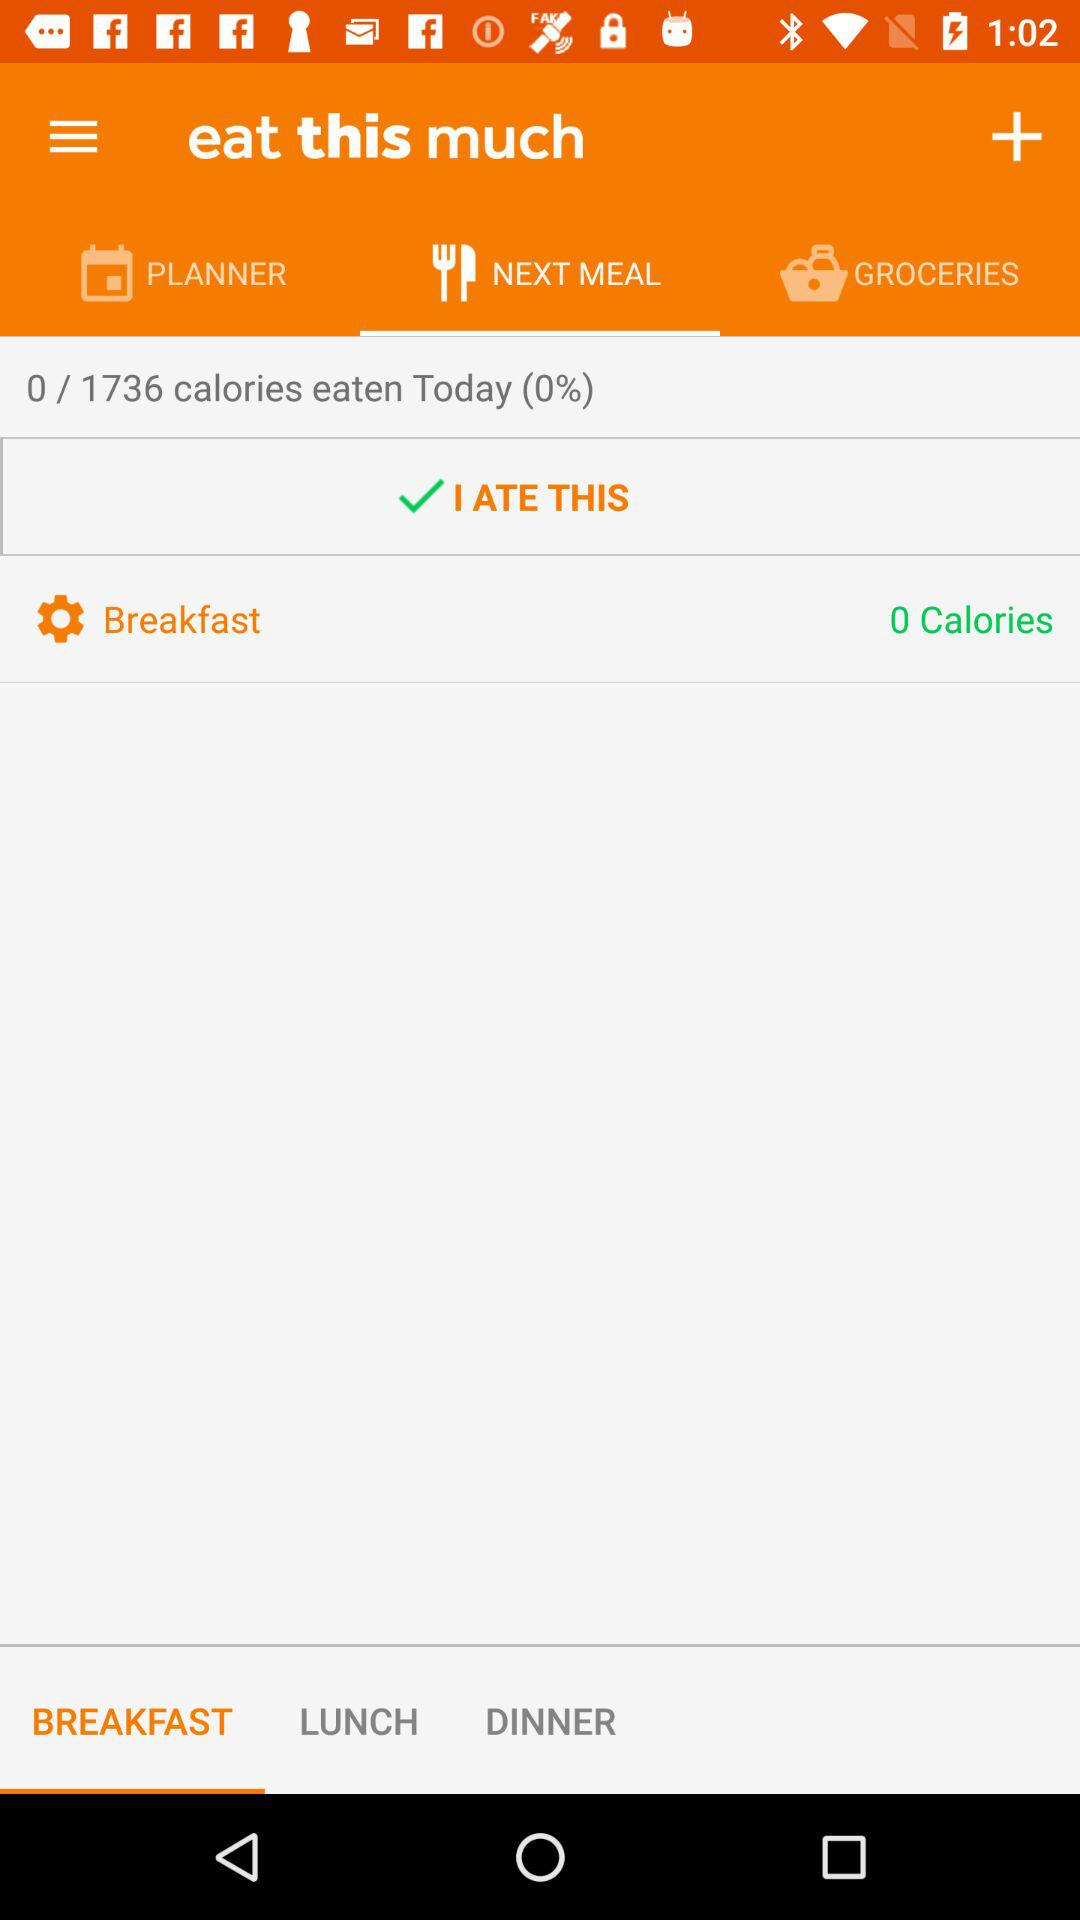How many calories have I eaten today?
Answer the question using a single word or phrase. 0 